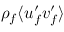Convert formula to latex. <formula><loc_0><loc_0><loc_500><loc_500>\rho _ { f } \langle u _ { f } ^ { \prime } v _ { f } ^ { \prime } \rangle</formula> 